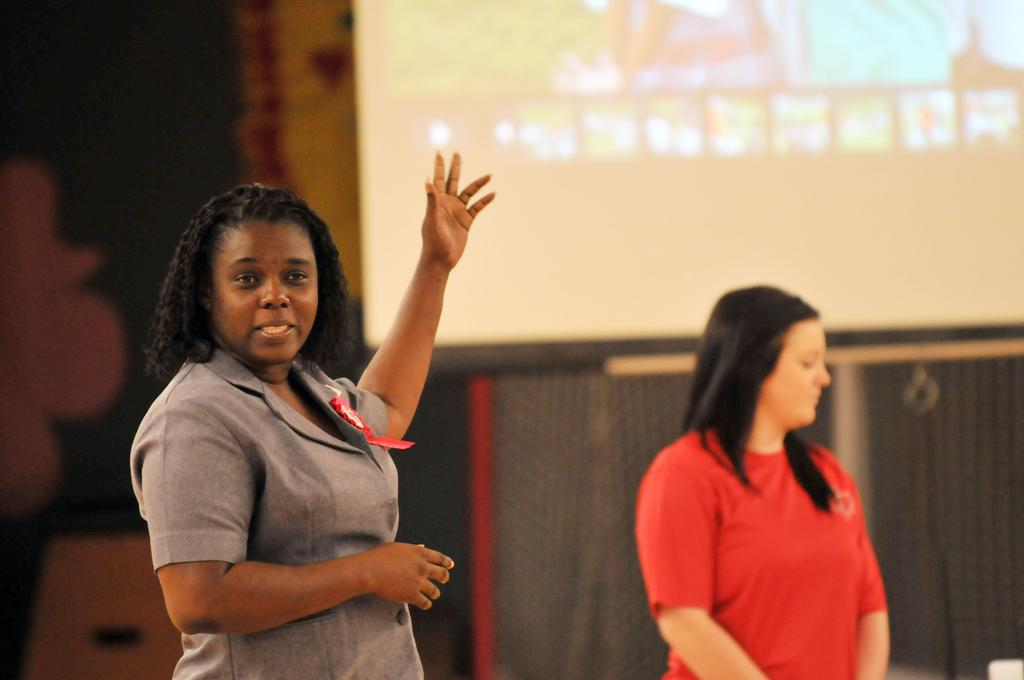How many people are in the image? There are two ladies in the image. What can be seen in the background of the image? There is a screen in the background of the image. What type of seed is being planted by the ladies in the image? There is no seed or planting activity depicted in the image; it features two ladies and a screen in the background. 